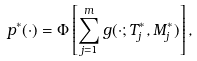Convert formula to latex. <formula><loc_0><loc_0><loc_500><loc_500>p ^ { * } ( \cdot ) = \Phi \left [ \sum _ { j = 1 } ^ { m } g ( \cdot ; T _ { j } ^ { * } , M _ { j } ^ { * } ) \right ] ,</formula> 